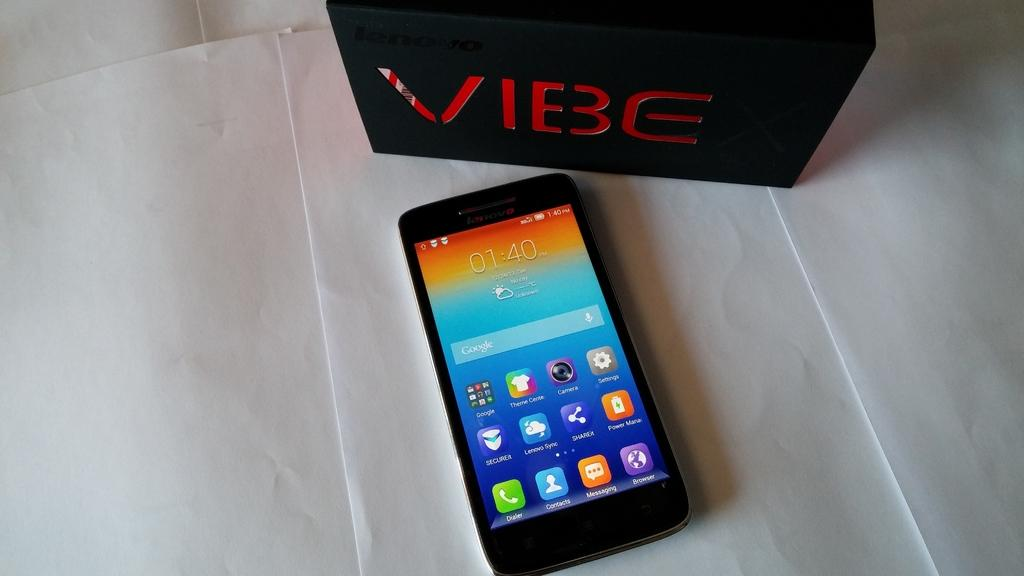<image>
Write a terse but informative summary of the picture. Vibe box with a cell phone in the front 